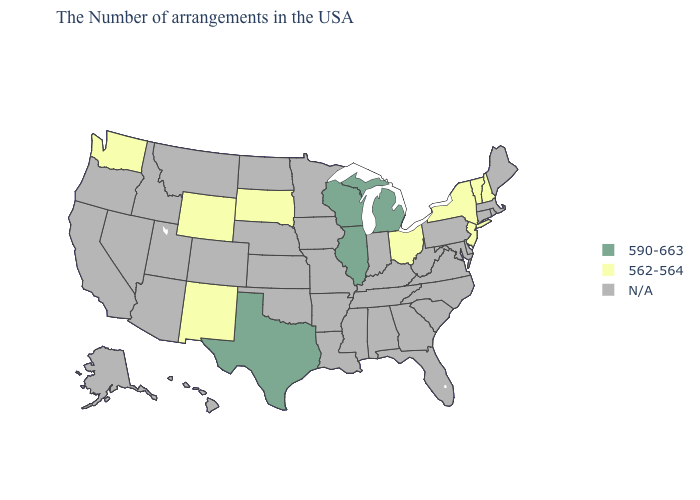What is the lowest value in the USA?
Write a very short answer. 562-564. What is the highest value in states that border Minnesota?
Concise answer only. 590-663. How many symbols are there in the legend?
Keep it brief. 3. What is the highest value in the USA?
Quick response, please. 590-663. Name the states that have a value in the range N/A?
Short answer required. Maine, Massachusetts, Rhode Island, Connecticut, Delaware, Maryland, Pennsylvania, Virginia, North Carolina, South Carolina, West Virginia, Florida, Georgia, Kentucky, Indiana, Alabama, Tennessee, Mississippi, Louisiana, Missouri, Arkansas, Minnesota, Iowa, Kansas, Nebraska, Oklahoma, North Dakota, Colorado, Utah, Montana, Arizona, Idaho, Nevada, California, Oregon, Alaska, Hawaii. Name the states that have a value in the range 590-663?
Keep it brief. Michigan, Wisconsin, Illinois, Texas. Name the states that have a value in the range 562-564?
Short answer required. New Hampshire, Vermont, New York, New Jersey, Ohio, South Dakota, Wyoming, New Mexico, Washington. What is the value of Arkansas?
Answer briefly. N/A. What is the lowest value in states that border Ohio?
Short answer required. 590-663. Does Michigan have the highest value in the USA?
Answer briefly. Yes. Name the states that have a value in the range N/A?
Answer briefly. Maine, Massachusetts, Rhode Island, Connecticut, Delaware, Maryland, Pennsylvania, Virginia, North Carolina, South Carolina, West Virginia, Florida, Georgia, Kentucky, Indiana, Alabama, Tennessee, Mississippi, Louisiana, Missouri, Arkansas, Minnesota, Iowa, Kansas, Nebraska, Oklahoma, North Dakota, Colorado, Utah, Montana, Arizona, Idaho, Nevada, California, Oregon, Alaska, Hawaii. Name the states that have a value in the range 590-663?
Answer briefly. Michigan, Wisconsin, Illinois, Texas. Name the states that have a value in the range 562-564?
Give a very brief answer. New Hampshire, Vermont, New York, New Jersey, Ohio, South Dakota, Wyoming, New Mexico, Washington. 